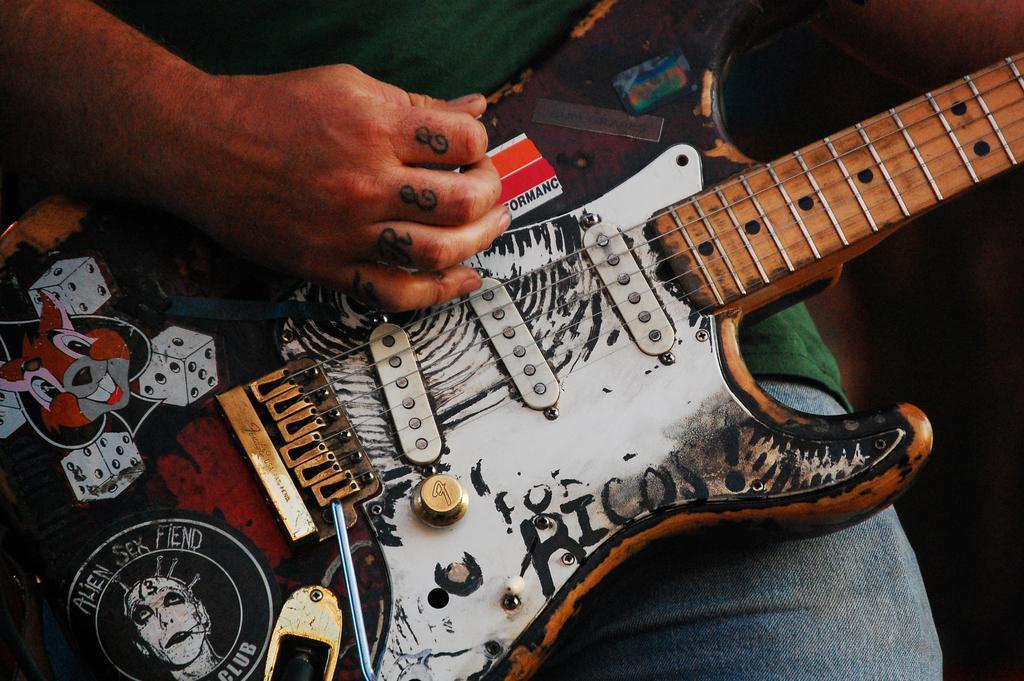Describe this image in one or two sentences. In this picture we can see a person holding guitar and playing it and this person wore green color shirt. 